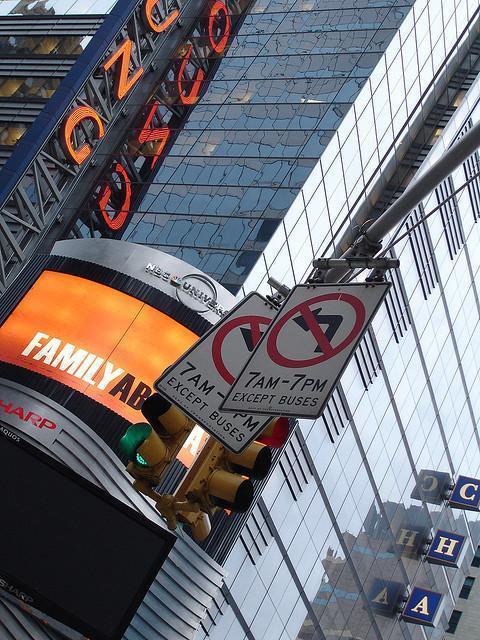How many traffic lights are here?
Give a very brief answer. 2. 